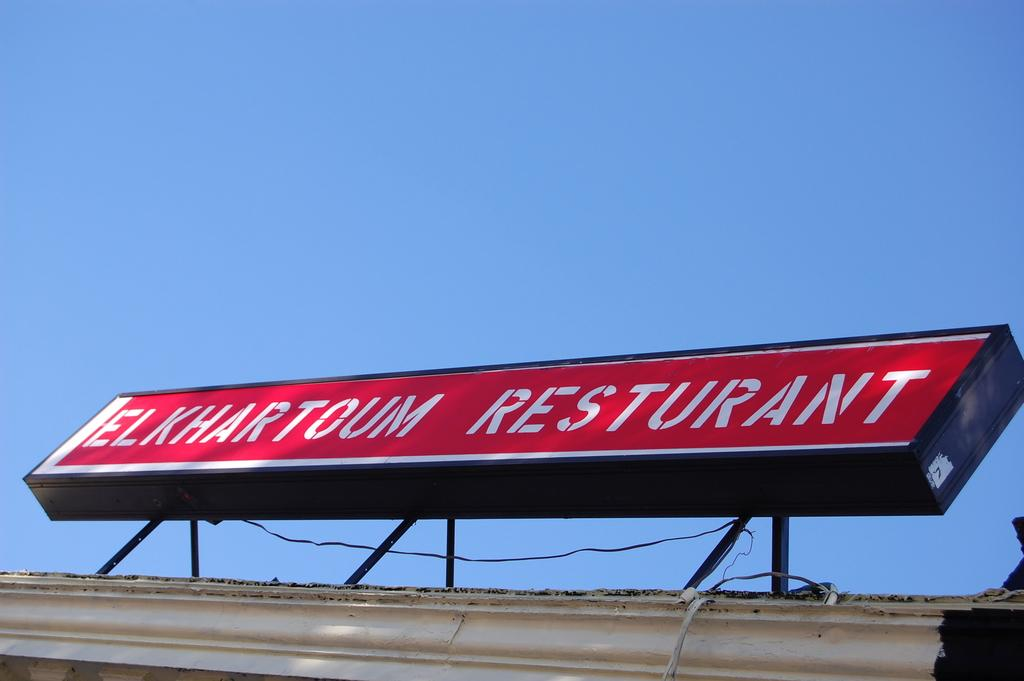<image>
Provide a brief description of the given image. A red signboard for the Elkhartoum Resturant sitting on a roof. 